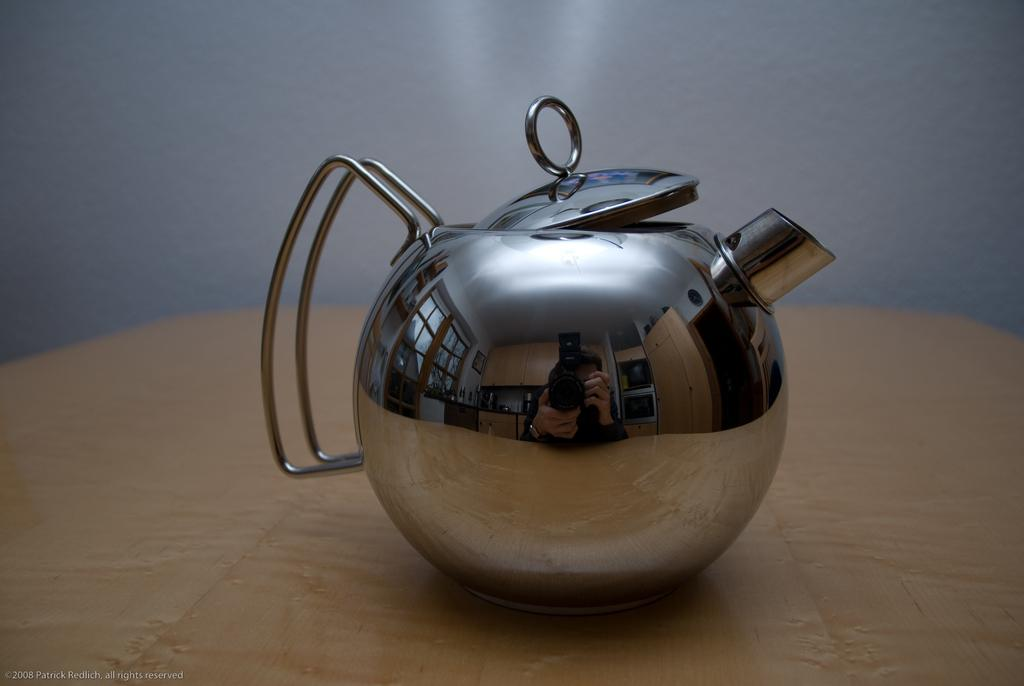What is the main object in the center of the image? There is a kettle in the center of the image. Where is the kettle located? The kettle is on a wooden table. How many beans are on the chair in the image? There is no chair or beans present in the image; it only features a kettle on a wooden table. 